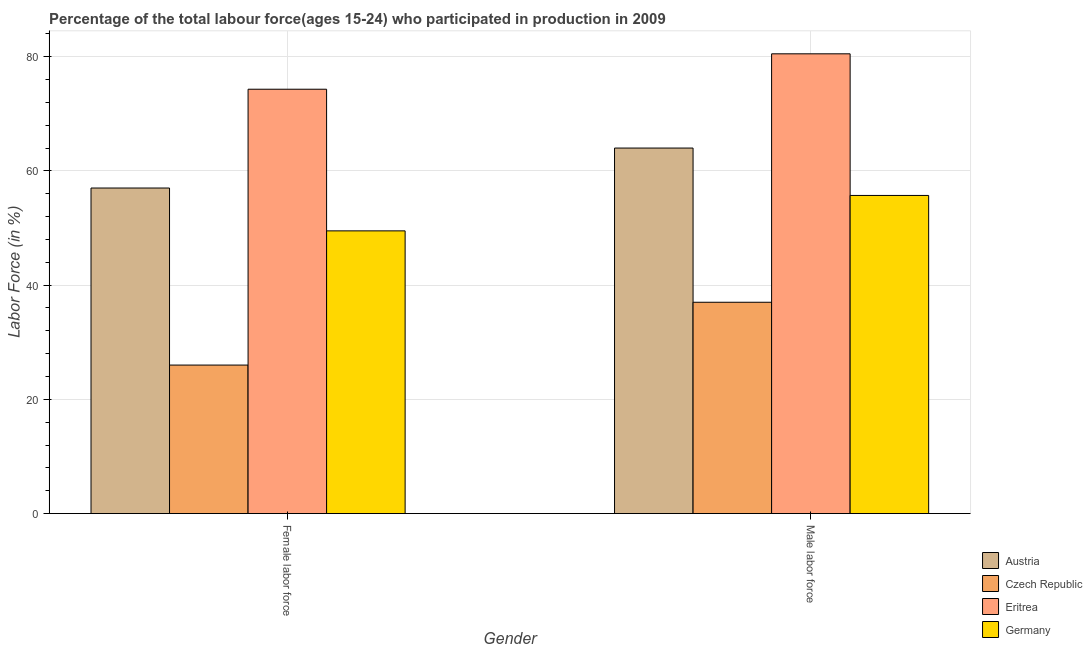How many bars are there on the 2nd tick from the left?
Your answer should be compact. 4. What is the label of the 1st group of bars from the left?
Your answer should be compact. Female labor force. What is the percentage of female labor force in Germany?
Provide a succinct answer. 49.5. Across all countries, what is the maximum percentage of female labor force?
Your response must be concise. 74.3. Across all countries, what is the minimum percentage of female labor force?
Provide a short and direct response. 26. In which country was the percentage of male labour force maximum?
Your response must be concise. Eritrea. In which country was the percentage of male labour force minimum?
Make the answer very short. Czech Republic. What is the total percentage of male labour force in the graph?
Provide a succinct answer. 237.2. What is the difference between the percentage of female labor force in Czech Republic and that in Eritrea?
Ensure brevity in your answer.  -48.3. What is the difference between the percentage of female labor force in Austria and the percentage of male labour force in Germany?
Your answer should be compact. 1.3. What is the average percentage of male labour force per country?
Your answer should be very brief. 59.3. What is the difference between the percentage of male labour force and percentage of female labor force in Eritrea?
Your response must be concise. 6.2. What is the ratio of the percentage of male labour force in Czech Republic to that in Eritrea?
Keep it short and to the point. 0.46. In how many countries, is the percentage of male labour force greater than the average percentage of male labour force taken over all countries?
Your response must be concise. 2. What does the 2nd bar from the left in Male labor force represents?
Make the answer very short. Czech Republic. Are the values on the major ticks of Y-axis written in scientific E-notation?
Keep it short and to the point. No. Does the graph contain any zero values?
Your answer should be compact. No. Where does the legend appear in the graph?
Make the answer very short. Bottom right. What is the title of the graph?
Your answer should be very brief. Percentage of the total labour force(ages 15-24) who participated in production in 2009. Does "Nigeria" appear as one of the legend labels in the graph?
Make the answer very short. No. What is the label or title of the X-axis?
Ensure brevity in your answer.  Gender. What is the label or title of the Y-axis?
Your answer should be compact. Labor Force (in %). What is the Labor Force (in %) of Austria in Female labor force?
Your answer should be very brief. 57. What is the Labor Force (in %) in Czech Republic in Female labor force?
Keep it short and to the point. 26. What is the Labor Force (in %) in Eritrea in Female labor force?
Provide a short and direct response. 74.3. What is the Labor Force (in %) in Germany in Female labor force?
Your answer should be very brief. 49.5. What is the Labor Force (in %) in Austria in Male labor force?
Provide a succinct answer. 64. What is the Labor Force (in %) of Czech Republic in Male labor force?
Your answer should be compact. 37. What is the Labor Force (in %) of Eritrea in Male labor force?
Your answer should be very brief. 80.5. What is the Labor Force (in %) in Germany in Male labor force?
Offer a very short reply. 55.7. Across all Gender, what is the maximum Labor Force (in %) of Austria?
Your answer should be compact. 64. Across all Gender, what is the maximum Labor Force (in %) of Czech Republic?
Offer a very short reply. 37. Across all Gender, what is the maximum Labor Force (in %) of Eritrea?
Give a very brief answer. 80.5. Across all Gender, what is the maximum Labor Force (in %) in Germany?
Offer a terse response. 55.7. Across all Gender, what is the minimum Labor Force (in %) in Austria?
Make the answer very short. 57. Across all Gender, what is the minimum Labor Force (in %) in Eritrea?
Offer a terse response. 74.3. Across all Gender, what is the minimum Labor Force (in %) of Germany?
Make the answer very short. 49.5. What is the total Labor Force (in %) in Austria in the graph?
Offer a terse response. 121. What is the total Labor Force (in %) in Eritrea in the graph?
Ensure brevity in your answer.  154.8. What is the total Labor Force (in %) in Germany in the graph?
Your answer should be very brief. 105.2. What is the difference between the Labor Force (in %) in Germany in Female labor force and that in Male labor force?
Your response must be concise. -6.2. What is the difference between the Labor Force (in %) in Austria in Female labor force and the Labor Force (in %) in Czech Republic in Male labor force?
Offer a terse response. 20. What is the difference between the Labor Force (in %) of Austria in Female labor force and the Labor Force (in %) of Eritrea in Male labor force?
Provide a short and direct response. -23.5. What is the difference between the Labor Force (in %) of Czech Republic in Female labor force and the Labor Force (in %) of Eritrea in Male labor force?
Make the answer very short. -54.5. What is the difference between the Labor Force (in %) of Czech Republic in Female labor force and the Labor Force (in %) of Germany in Male labor force?
Your answer should be very brief. -29.7. What is the average Labor Force (in %) of Austria per Gender?
Keep it short and to the point. 60.5. What is the average Labor Force (in %) of Czech Republic per Gender?
Offer a very short reply. 31.5. What is the average Labor Force (in %) in Eritrea per Gender?
Provide a short and direct response. 77.4. What is the average Labor Force (in %) of Germany per Gender?
Your answer should be very brief. 52.6. What is the difference between the Labor Force (in %) of Austria and Labor Force (in %) of Czech Republic in Female labor force?
Offer a terse response. 31. What is the difference between the Labor Force (in %) in Austria and Labor Force (in %) in Eritrea in Female labor force?
Provide a succinct answer. -17.3. What is the difference between the Labor Force (in %) of Austria and Labor Force (in %) of Germany in Female labor force?
Your answer should be compact. 7.5. What is the difference between the Labor Force (in %) of Czech Republic and Labor Force (in %) of Eritrea in Female labor force?
Keep it short and to the point. -48.3. What is the difference between the Labor Force (in %) in Czech Republic and Labor Force (in %) in Germany in Female labor force?
Make the answer very short. -23.5. What is the difference between the Labor Force (in %) in Eritrea and Labor Force (in %) in Germany in Female labor force?
Your response must be concise. 24.8. What is the difference between the Labor Force (in %) of Austria and Labor Force (in %) of Eritrea in Male labor force?
Offer a terse response. -16.5. What is the difference between the Labor Force (in %) of Austria and Labor Force (in %) of Germany in Male labor force?
Your answer should be very brief. 8.3. What is the difference between the Labor Force (in %) of Czech Republic and Labor Force (in %) of Eritrea in Male labor force?
Your answer should be very brief. -43.5. What is the difference between the Labor Force (in %) in Czech Republic and Labor Force (in %) in Germany in Male labor force?
Give a very brief answer. -18.7. What is the difference between the Labor Force (in %) of Eritrea and Labor Force (in %) of Germany in Male labor force?
Provide a succinct answer. 24.8. What is the ratio of the Labor Force (in %) of Austria in Female labor force to that in Male labor force?
Make the answer very short. 0.89. What is the ratio of the Labor Force (in %) in Czech Republic in Female labor force to that in Male labor force?
Provide a succinct answer. 0.7. What is the ratio of the Labor Force (in %) of Eritrea in Female labor force to that in Male labor force?
Offer a very short reply. 0.92. What is the ratio of the Labor Force (in %) in Germany in Female labor force to that in Male labor force?
Make the answer very short. 0.89. What is the difference between the highest and the second highest Labor Force (in %) of Austria?
Make the answer very short. 7. What is the difference between the highest and the second highest Labor Force (in %) of Czech Republic?
Provide a short and direct response. 11. What is the difference between the highest and the second highest Labor Force (in %) in Eritrea?
Provide a short and direct response. 6.2. What is the difference between the highest and the lowest Labor Force (in %) in Czech Republic?
Ensure brevity in your answer.  11. What is the difference between the highest and the lowest Labor Force (in %) in Eritrea?
Your response must be concise. 6.2. What is the difference between the highest and the lowest Labor Force (in %) in Germany?
Give a very brief answer. 6.2. 